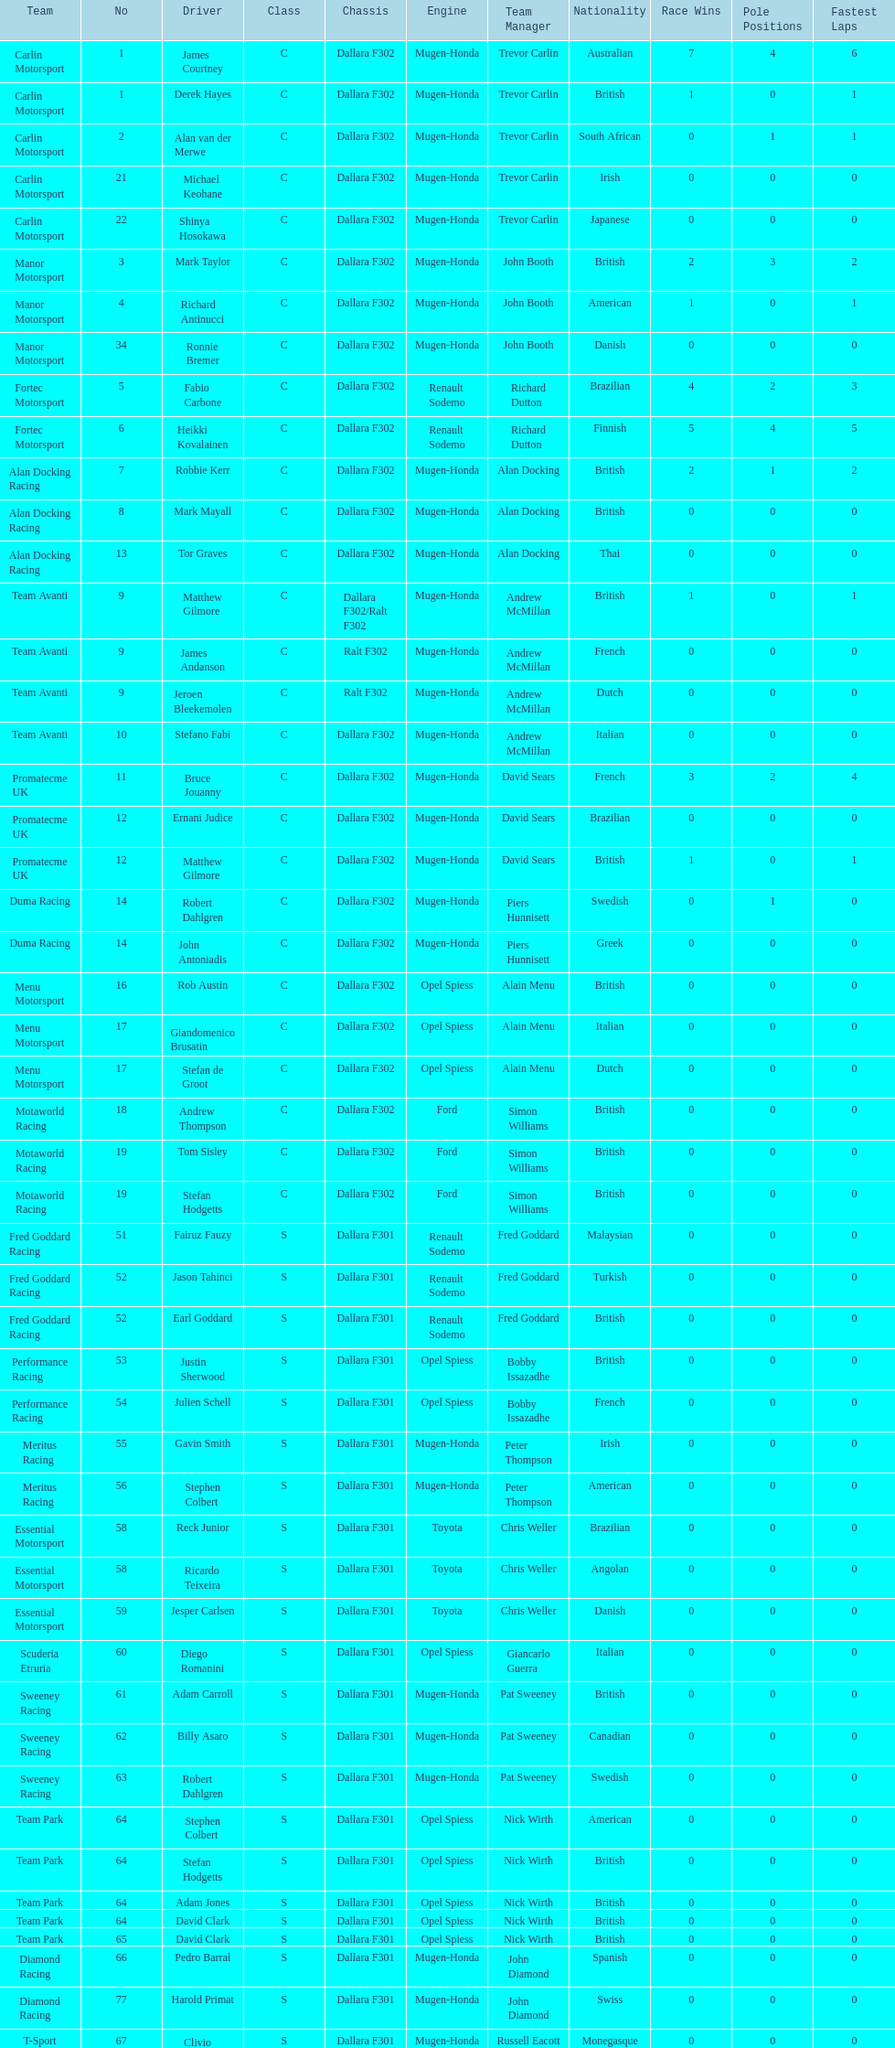What is the average number of teams that had a mugen-honda engine? 24. 